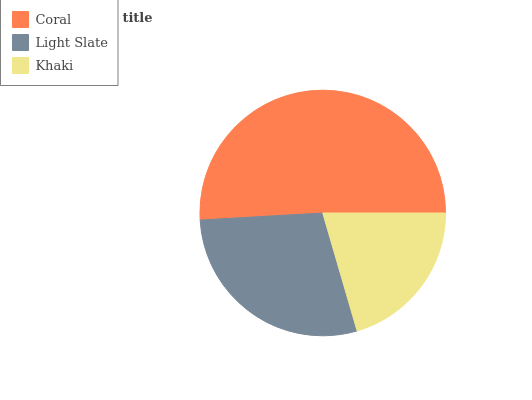Is Khaki the minimum?
Answer yes or no. Yes. Is Coral the maximum?
Answer yes or no. Yes. Is Light Slate the minimum?
Answer yes or no. No. Is Light Slate the maximum?
Answer yes or no. No. Is Coral greater than Light Slate?
Answer yes or no. Yes. Is Light Slate less than Coral?
Answer yes or no. Yes. Is Light Slate greater than Coral?
Answer yes or no. No. Is Coral less than Light Slate?
Answer yes or no. No. Is Light Slate the high median?
Answer yes or no. Yes. Is Light Slate the low median?
Answer yes or no. Yes. Is Khaki the high median?
Answer yes or no. No. Is Coral the low median?
Answer yes or no. No. 